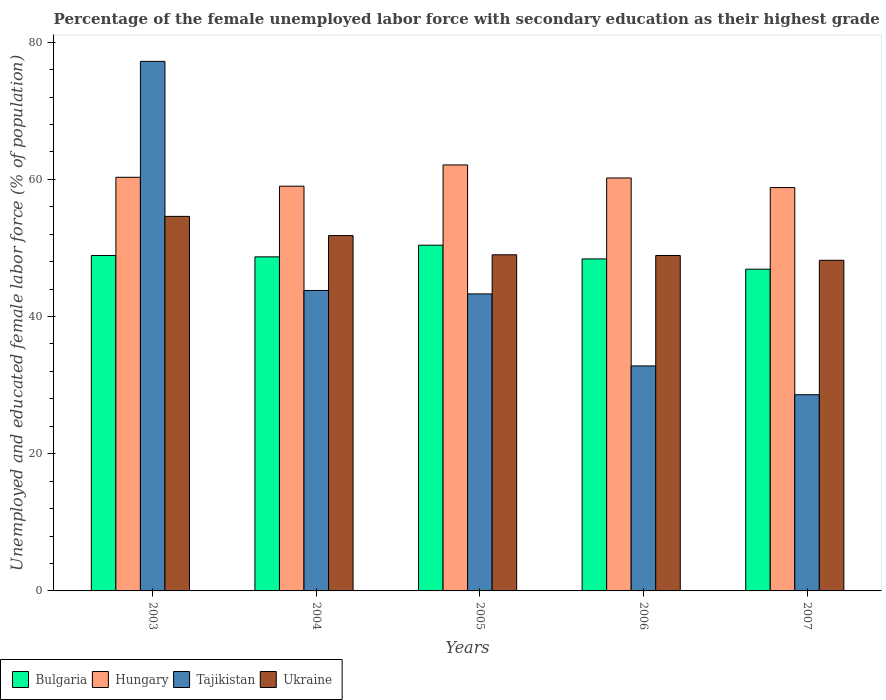How many different coloured bars are there?
Make the answer very short. 4. How many groups of bars are there?
Give a very brief answer. 5. Are the number of bars on each tick of the X-axis equal?
Your answer should be compact. Yes. What is the label of the 3rd group of bars from the left?
Keep it short and to the point. 2005. In how many cases, is the number of bars for a given year not equal to the number of legend labels?
Offer a terse response. 0. What is the percentage of the unemployed female labor force with secondary education in Bulgaria in 2005?
Offer a very short reply. 50.4. Across all years, what is the maximum percentage of the unemployed female labor force with secondary education in Tajikistan?
Provide a succinct answer. 77.2. Across all years, what is the minimum percentage of the unemployed female labor force with secondary education in Tajikistan?
Offer a very short reply. 28.6. In which year was the percentage of the unemployed female labor force with secondary education in Ukraine maximum?
Your response must be concise. 2003. In which year was the percentage of the unemployed female labor force with secondary education in Tajikistan minimum?
Provide a short and direct response. 2007. What is the total percentage of the unemployed female labor force with secondary education in Tajikistan in the graph?
Provide a short and direct response. 225.7. What is the difference between the percentage of the unemployed female labor force with secondary education in Tajikistan in 2003 and that in 2007?
Keep it short and to the point. 48.6. What is the average percentage of the unemployed female labor force with secondary education in Tajikistan per year?
Keep it short and to the point. 45.14. In the year 2004, what is the difference between the percentage of the unemployed female labor force with secondary education in Hungary and percentage of the unemployed female labor force with secondary education in Bulgaria?
Offer a terse response. 10.3. In how many years, is the percentage of the unemployed female labor force with secondary education in Hungary greater than 16 %?
Your response must be concise. 5. What is the ratio of the percentage of the unemployed female labor force with secondary education in Bulgaria in 2004 to that in 2007?
Your answer should be very brief. 1.04. Is the difference between the percentage of the unemployed female labor force with secondary education in Hungary in 2004 and 2007 greater than the difference between the percentage of the unemployed female labor force with secondary education in Bulgaria in 2004 and 2007?
Ensure brevity in your answer.  No. What is the difference between the highest and the second highest percentage of the unemployed female labor force with secondary education in Tajikistan?
Ensure brevity in your answer.  33.4. Is it the case that in every year, the sum of the percentage of the unemployed female labor force with secondary education in Bulgaria and percentage of the unemployed female labor force with secondary education in Ukraine is greater than the sum of percentage of the unemployed female labor force with secondary education in Hungary and percentage of the unemployed female labor force with secondary education in Tajikistan?
Offer a very short reply. No. What does the 4th bar from the left in 2003 represents?
Your answer should be compact. Ukraine. What does the 2nd bar from the right in 2006 represents?
Give a very brief answer. Tajikistan. Are the values on the major ticks of Y-axis written in scientific E-notation?
Ensure brevity in your answer.  No. Does the graph contain any zero values?
Offer a terse response. No. Does the graph contain grids?
Offer a terse response. No. Where does the legend appear in the graph?
Ensure brevity in your answer.  Bottom left. How many legend labels are there?
Ensure brevity in your answer.  4. What is the title of the graph?
Provide a short and direct response. Percentage of the female unemployed labor force with secondary education as their highest grade. What is the label or title of the Y-axis?
Keep it short and to the point. Unemployed and educated female labor force (% of population). What is the Unemployed and educated female labor force (% of population) of Bulgaria in 2003?
Your response must be concise. 48.9. What is the Unemployed and educated female labor force (% of population) of Hungary in 2003?
Offer a very short reply. 60.3. What is the Unemployed and educated female labor force (% of population) of Tajikistan in 2003?
Keep it short and to the point. 77.2. What is the Unemployed and educated female labor force (% of population) in Ukraine in 2003?
Your response must be concise. 54.6. What is the Unemployed and educated female labor force (% of population) of Bulgaria in 2004?
Provide a succinct answer. 48.7. What is the Unemployed and educated female labor force (% of population) of Hungary in 2004?
Provide a succinct answer. 59. What is the Unemployed and educated female labor force (% of population) of Tajikistan in 2004?
Your response must be concise. 43.8. What is the Unemployed and educated female labor force (% of population) in Ukraine in 2004?
Make the answer very short. 51.8. What is the Unemployed and educated female labor force (% of population) in Bulgaria in 2005?
Your response must be concise. 50.4. What is the Unemployed and educated female labor force (% of population) in Hungary in 2005?
Provide a succinct answer. 62.1. What is the Unemployed and educated female labor force (% of population) in Tajikistan in 2005?
Offer a very short reply. 43.3. What is the Unemployed and educated female labor force (% of population) in Ukraine in 2005?
Ensure brevity in your answer.  49. What is the Unemployed and educated female labor force (% of population) in Bulgaria in 2006?
Offer a very short reply. 48.4. What is the Unemployed and educated female labor force (% of population) in Hungary in 2006?
Give a very brief answer. 60.2. What is the Unemployed and educated female labor force (% of population) of Tajikistan in 2006?
Provide a succinct answer. 32.8. What is the Unemployed and educated female labor force (% of population) of Ukraine in 2006?
Your answer should be compact. 48.9. What is the Unemployed and educated female labor force (% of population) in Bulgaria in 2007?
Offer a very short reply. 46.9. What is the Unemployed and educated female labor force (% of population) of Hungary in 2007?
Your answer should be very brief. 58.8. What is the Unemployed and educated female labor force (% of population) in Tajikistan in 2007?
Provide a succinct answer. 28.6. What is the Unemployed and educated female labor force (% of population) of Ukraine in 2007?
Ensure brevity in your answer.  48.2. Across all years, what is the maximum Unemployed and educated female labor force (% of population) in Bulgaria?
Your answer should be very brief. 50.4. Across all years, what is the maximum Unemployed and educated female labor force (% of population) in Hungary?
Your answer should be very brief. 62.1. Across all years, what is the maximum Unemployed and educated female labor force (% of population) of Tajikistan?
Offer a terse response. 77.2. Across all years, what is the maximum Unemployed and educated female labor force (% of population) in Ukraine?
Offer a terse response. 54.6. Across all years, what is the minimum Unemployed and educated female labor force (% of population) in Bulgaria?
Keep it short and to the point. 46.9. Across all years, what is the minimum Unemployed and educated female labor force (% of population) of Hungary?
Give a very brief answer. 58.8. Across all years, what is the minimum Unemployed and educated female labor force (% of population) of Tajikistan?
Give a very brief answer. 28.6. Across all years, what is the minimum Unemployed and educated female labor force (% of population) in Ukraine?
Make the answer very short. 48.2. What is the total Unemployed and educated female labor force (% of population) in Bulgaria in the graph?
Ensure brevity in your answer.  243.3. What is the total Unemployed and educated female labor force (% of population) of Hungary in the graph?
Keep it short and to the point. 300.4. What is the total Unemployed and educated female labor force (% of population) of Tajikistan in the graph?
Ensure brevity in your answer.  225.7. What is the total Unemployed and educated female labor force (% of population) in Ukraine in the graph?
Offer a terse response. 252.5. What is the difference between the Unemployed and educated female labor force (% of population) of Hungary in 2003 and that in 2004?
Keep it short and to the point. 1.3. What is the difference between the Unemployed and educated female labor force (% of population) in Tajikistan in 2003 and that in 2004?
Keep it short and to the point. 33.4. What is the difference between the Unemployed and educated female labor force (% of population) of Ukraine in 2003 and that in 2004?
Make the answer very short. 2.8. What is the difference between the Unemployed and educated female labor force (% of population) of Bulgaria in 2003 and that in 2005?
Give a very brief answer. -1.5. What is the difference between the Unemployed and educated female labor force (% of population) of Hungary in 2003 and that in 2005?
Your answer should be compact. -1.8. What is the difference between the Unemployed and educated female labor force (% of population) of Tajikistan in 2003 and that in 2005?
Your response must be concise. 33.9. What is the difference between the Unemployed and educated female labor force (% of population) of Ukraine in 2003 and that in 2005?
Your response must be concise. 5.6. What is the difference between the Unemployed and educated female labor force (% of population) in Tajikistan in 2003 and that in 2006?
Your answer should be compact. 44.4. What is the difference between the Unemployed and educated female labor force (% of population) in Bulgaria in 2003 and that in 2007?
Ensure brevity in your answer.  2. What is the difference between the Unemployed and educated female labor force (% of population) of Hungary in 2003 and that in 2007?
Make the answer very short. 1.5. What is the difference between the Unemployed and educated female labor force (% of population) in Tajikistan in 2003 and that in 2007?
Your answer should be very brief. 48.6. What is the difference between the Unemployed and educated female labor force (% of population) of Bulgaria in 2004 and that in 2005?
Keep it short and to the point. -1.7. What is the difference between the Unemployed and educated female labor force (% of population) in Tajikistan in 2004 and that in 2005?
Make the answer very short. 0.5. What is the difference between the Unemployed and educated female labor force (% of population) in Ukraine in 2004 and that in 2005?
Your answer should be compact. 2.8. What is the difference between the Unemployed and educated female labor force (% of population) in Hungary in 2004 and that in 2006?
Keep it short and to the point. -1.2. What is the difference between the Unemployed and educated female labor force (% of population) of Bulgaria in 2004 and that in 2007?
Ensure brevity in your answer.  1.8. What is the difference between the Unemployed and educated female labor force (% of population) in Tajikistan in 2004 and that in 2007?
Provide a short and direct response. 15.2. What is the difference between the Unemployed and educated female labor force (% of population) in Ukraine in 2005 and that in 2006?
Your answer should be compact. 0.1. What is the difference between the Unemployed and educated female labor force (% of population) of Tajikistan in 2005 and that in 2007?
Make the answer very short. 14.7. What is the difference between the Unemployed and educated female labor force (% of population) of Bulgaria in 2006 and that in 2007?
Make the answer very short. 1.5. What is the difference between the Unemployed and educated female labor force (% of population) of Tajikistan in 2006 and that in 2007?
Offer a terse response. 4.2. What is the difference between the Unemployed and educated female labor force (% of population) in Bulgaria in 2003 and the Unemployed and educated female labor force (% of population) in Hungary in 2004?
Your answer should be compact. -10.1. What is the difference between the Unemployed and educated female labor force (% of population) in Bulgaria in 2003 and the Unemployed and educated female labor force (% of population) in Tajikistan in 2004?
Offer a very short reply. 5.1. What is the difference between the Unemployed and educated female labor force (% of population) in Bulgaria in 2003 and the Unemployed and educated female labor force (% of population) in Ukraine in 2004?
Make the answer very short. -2.9. What is the difference between the Unemployed and educated female labor force (% of population) in Hungary in 2003 and the Unemployed and educated female labor force (% of population) in Ukraine in 2004?
Your response must be concise. 8.5. What is the difference between the Unemployed and educated female labor force (% of population) in Tajikistan in 2003 and the Unemployed and educated female labor force (% of population) in Ukraine in 2004?
Offer a terse response. 25.4. What is the difference between the Unemployed and educated female labor force (% of population) in Bulgaria in 2003 and the Unemployed and educated female labor force (% of population) in Hungary in 2005?
Make the answer very short. -13.2. What is the difference between the Unemployed and educated female labor force (% of population) in Bulgaria in 2003 and the Unemployed and educated female labor force (% of population) in Tajikistan in 2005?
Offer a terse response. 5.6. What is the difference between the Unemployed and educated female labor force (% of population) of Bulgaria in 2003 and the Unemployed and educated female labor force (% of population) of Ukraine in 2005?
Keep it short and to the point. -0.1. What is the difference between the Unemployed and educated female labor force (% of population) in Hungary in 2003 and the Unemployed and educated female labor force (% of population) in Ukraine in 2005?
Give a very brief answer. 11.3. What is the difference between the Unemployed and educated female labor force (% of population) in Tajikistan in 2003 and the Unemployed and educated female labor force (% of population) in Ukraine in 2005?
Your response must be concise. 28.2. What is the difference between the Unemployed and educated female labor force (% of population) in Bulgaria in 2003 and the Unemployed and educated female labor force (% of population) in Tajikistan in 2006?
Provide a succinct answer. 16.1. What is the difference between the Unemployed and educated female labor force (% of population) of Bulgaria in 2003 and the Unemployed and educated female labor force (% of population) of Ukraine in 2006?
Your answer should be compact. 0. What is the difference between the Unemployed and educated female labor force (% of population) in Tajikistan in 2003 and the Unemployed and educated female labor force (% of population) in Ukraine in 2006?
Your answer should be compact. 28.3. What is the difference between the Unemployed and educated female labor force (% of population) in Bulgaria in 2003 and the Unemployed and educated female labor force (% of population) in Tajikistan in 2007?
Provide a short and direct response. 20.3. What is the difference between the Unemployed and educated female labor force (% of population) of Hungary in 2003 and the Unemployed and educated female labor force (% of population) of Tajikistan in 2007?
Provide a succinct answer. 31.7. What is the difference between the Unemployed and educated female labor force (% of population) in Tajikistan in 2003 and the Unemployed and educated female labor force (% of population) in Ukraine in 2007?
Provide a short and direct response. 29. What is the difference between the Unemployed and educated female labor force (% of population) in Bulgaria in 2004 and the Unemployed and educated female labor force (% of population) in Tajikistan in 2005?
Give a very brief answer. 5.4. What is the difference between the Unemployed and educated female labor force (% of population) of Bulgaria in 2004 and the Unemployed and educated female labor force (% of population) of Ukraine in 2005?
Offer a terse response. -0.3. What is the difference between the Unemployed and educated female labor force (% of population) in Tajikistan in 2004 and the Unemployed and educated female labor force (% of population) in Ukraine in 2005?
Offer a very short reply. -5.2. What is the difference between the Unemployed and educated female labor force (% of population) of Bulgaria in 2004 and the Unemployed and educated female labor force (% of population) of Tajikistan in 2006?
Your answer should be very brief. 15.9. What is the difference between the Unemployed and educated female labor force (% of population) in Bulgaria in 2004 and the Unemployed and educated female labor force (% of population) in Ukraine in 2006?
Keep it short and to the point. -0.2. What is the difference between the Unemployed and educated female labor force (% of population) in Hungary in 2004 and the Unemployed and educated female labor force (% of population) in Tajikistan in 2006?
Your answer should be very brief. 26.2. What is the difference between the Unemployed and educated female labor force (% of population) of Hungary in 2004 and the Unemployed and educated female labor force (% of population) of Ukraine in 2006?
Your response must be concise. 10.1. What is the difference between the Unemployed and educated female labor force (% of population) of Bulgaria in 2004 and the Unemployed and educated female labor force (% of population) of Hungary in 2007?
Your response must be concise. -10.1. What is the difference between the Unemployed and educated female labor force (% of population) in Bulgaria in 2004 and the Unemployed and educated female labor force (% of population) in Tajikistan in 2007?
Keep it short and to the point. 20.1. What is the difference between the Unemployed and educated female labor force (% of population) of Hungary in 2004 and the Unemployed and educated female labor force (% of population) of Tajikistan in 2007?
Your answer should be very brief. 30.4. What is the difference between the Unemployed and educated female labor force (% of population) of Hungary in 2004 and the Unemployed and educated female labor force (% of population) of Ukraine in 2007?
Offer a terse response. 10.8. What is the difference between the Unemployed and educated female labor force (% of population) of Tajikistan in 2004 and the Unemployed and educated female labor force (% of population) of Ukraine in 2007?
Keep it short and to the point. -4.4. What is the difference between the Unemployed and educated female labor force (% of population) in Bulgaria in 2005 and the Unemployed and educated female labor force (% of population) in Hungary in 2006?
Your response must be concise. -9.8. What is the difference between the Unemployed and educated female labor force (% of population) in Hungary in 2005 and the Unemployed and educated female labor force (% of population) in Tajikistan in 2006?
Offer a very short reply. 29.3. What is the difference between the Unemployed and educated female labor force (% of population) of Hungary in 2005 and the Unemployed and educated female labor force (% of population) of Ukraine in 2006?
Your answer should be compact. 13.2. What is the difference between the Unemployed and educated female labor force (% of population) in Bulgaria in 2005 and the Unemployed and educated female labor force (% of population) in Hungary in 2007?
Keep it short and to the point. -8.4. What is the difference between the Unemployed and educated female labor force (% of population) in Bulgaria in 2005 and the Unemployed and educated female labor force (% of population) in Tajikistan in 2007?
Provide a succinct answer. 21.8. What is the difference between the Unemployed and educated female labor force (% of population) in Hungary in 2005 and the Unemployed and educated female labor force (% of population) in Tajikistan in 2007?
Provide a succinct answer. 33.5. What is the difference between the Unemployed and educated female labor force (% of population) in Hungary in 2005 and the Unemployed and educated female labor force (% of population) in Ukraine in 2007?
Offer a very short reply. 13.9. What is the difference between the Unemployed and educated female labor force (% of population) in Tajikistan in 2005 and the Unemployed and educated female labor force (% of population) in Ukraine in 2007?
Your response must be concise. -4.9. What is the difference between the Unemployed and educated female labor force (% of population) in Bulgaria in 2006 and the Unemployed and educated female labor force (% of population) in Hungary in 2007?
Provide a succinct answer. -10.4. What is the difference between the Unemployed and educated female labor force (% of population) of Bulgaria in 2006 and the Unemployed and educated female labor force (% of population) of Tajikistan in 2007?
Provide a succinct answer. 19.8. What is the difference between the Unemployed and educated female labor force (% of population) in Hungary in 2006 and the Unemployed and educated female labor force (% of population) in Tajikistan in 2007?
Make the answer very short. 31.6. What is the difference between the Unemployed and educated female labor force (% of population) in Hungary in 2006 and the Unemployed and educated female labor force (% of population) in Ukraine in 2007?
Your answer should be very brief. 12. What is the difference between the Unemployed and educated female labor force (% of population) in Tajikistan in 2006 and the Unemployed and educated female labor force (% of population) in Ukraine in 2007?
Keep it short and to the point. -15.4. What is the average Unemployed and educated female labor force (% of population) in Bulgaria per year?
Make the answer very short. 48.66. What is the average Unemployed and educated female labor force (% of population) of Hungary per year?
Make the answer very short. 60.08. What is the average Unemployed and educated female labor force (% of population) in Tajikistan per year?
Give a very brief answer. 45.14. What is the average Unemployed and educated female labor force (% of population) of Ukraine per year?
Give a very brief answer. 50.5. In the year 2003, what is the difference between the Unemployed and educated female labor force (% of population) of Bulgaria and Unemployed and educated female labor force (% of population) of Hungary?
Your answer should be very brief. -11.4. In the year 2003, what is the difference between the Unemployed and educated female labor force (% of population) of Bulgaria and Unemployed and educated female labor force (% of population) of Tajikistan?
Give a very brief answer. -28.3. In the year 2003, what is the difference between the Unemployed and educated female labor force (% of population) of Hungary and Unemployed and educated female labor force (% of population) of Tajikistan?
Give a very brief answer. -16.9. In the year 2003, what is the difference between the Unemployed and educated female labor force (% of population) in Tajikistan and Unemployed and educated female labor force (% of population) in Ukraine?
Give a very brief answer. 22.6. In the year 2004, what is the difference between the Unemployed and educated female labor force (% of population) in Hungary and Unemployed and educated female labor force (% of population) in Ukraine?
Keep it short and to the point. 7.2. In the year 2005, what is the difference between the Unemployed and educated female labor force (% of population) of Bulgaria and Unemployed and educated female labor force (% of population) of Tajikistan?
Offer a very short reply. 7.1. In the year 2005, what is the difference between the Unemployed and educated female labor force (% of population) of Bulgaria and Unemployed and educated female labor force (% of population) of Ukraine?
Give a very brief answer. 1.4. In the year 2006, what is the difference between the Unemployed and educated female labor force (% of population) of Bulgaria and Unemployed and educated female labor force (% of population) of Hungary?
Your answer should be very brief. -11.8. In the year 2006, what is the difference between the Unemployed and educated female labor force (% of population) in Bulgaria and Unemployed and educated female labor force (% of population) in Ukraine?
Offer a terse response. -0.5. In the year 2006, what is the difference between the Unemployed and educated female labor force (% of population) in Hungary and Unemployed and educated female labor force (% of population) in Tajikistan?
Provide a short and direct response. 27.4. In the year 2006, what is the difference between the Unemployed and educated female labor force (% of population) of Hungary and Unemployed and educated female labor force (% of population) of Ukraine?
Your answer should be compact. 11.3. In the year 2006, what is the difference between the Unemployed and educated female labor force (% of population) in Tajikistan and Unemployed and educated female labor force (% of population) in Ukraine?
Keep it short and to the point. -16.1. In the year 2007, what is the difference between the Unemployed and educated female labor force (% of population) in Bulgaria and Unemployed and educated female labor force (% of population) in Ukraine?
Provide a succinct answer. -1.3. In the year 2007, what is the difference between the Unemployed and educated female labor force (% of population) in Hungary and Unemployed and educated female labor force (% of population) in Tajikistan?
Give a very brief answer. 30.2. In the year 2007, what is the difference between the Unemployed and educated female labor force (% of population) in Hungary and Unemployed and educated female labor force (% of population) in Ukraine?
Your answer should be compact. 10.6. In the year 2007, what is the difference between the Unemployed and educated female labor force (% of population) of Tajikistan and Unemployed and educated female labor force (% of population) of Ukraine?
Provide a short and direct response. -19.6. What is the ratio of the Unemployed and educated female labor force (% of population) in Bulgaria in 2003 to that in 2004?
Your answer should be very brief. 1. What is the ratio of the Unemployed and educated female labor force (% of population) in Hungary in 2003 to that in 2004?
Your answer should be compact. 1.02. What is the ratio of the Unemployed and educated female labor force (% of population) of Tajikistan in 2003 to that in 2004?
Provide a succinct answer. 1.76. What is the ratio of the Unemployed and educated female labor force (% of population) of Ukraine in 2003 to that in 2004?
Offer a terse response. 1.05. What is the ratio of the Unemployed and educated female labor force (% of population) of Bulgaria in 2003 to that in 2005?
Keep it short and to the point. 0.97. What is the ratio of the Unemployed and educated female labor force (% of population) in Hungary in 2003 to that in 2005?
Offer a terse response. 0.97. What is the ratio of the Unemployed and educated female labor force (% of population) of Tajikistan in 2003 to that in 2005?
Your answer should be very brief. 1.78. What is the ratio of the Unemployed and educated female labor force (% of population) of Ukraine in 2003 to that in 2005?
Keep it short and to the point. 1.11. What is the ratio of the Unemployed and educated female labor force (% of population) of Bulgaria in 2003 to that in 2006?
Provide a short and direct response. 1.01. What is the ratio of the Unemployed and educated female labor force (% of population) in Hungary in 2003 to that in 2006?
Offer a terse response. 1. What is the ratio of the Unemployed and educated female labor force (% of population) in Tajikistan in 2003 to that in 2006?
Your answer should be compact. 2.35. What is the ratio of the Unemployed and educated female labor force (% of population) in Ukraine in 2003 to that in 2006?
Provide a succinct answer. 1.12. What is the ratio of the Unemployed and educated female labor force (% of population) of Bulgaria in 2003 to that in 2007?
Your answer should be very brief. 1.04. What is the ratio of the Unemployed and educated female labor force (% of population) of Hungary in 2003 to that in 2007?
Make the answer very short. 1.03. What is the ratio of the Unemployed and educated female labor force (% of population) of Tajikistan in 2003 to that in 2007?
Your answer should be compact. 2.7. What is the ratio of the Unemployed and educated female labor force (% of population) in Ukraine in 2003 to that in 2007?
Provide a short and direct response. 1.13. What is the ratio of the Unemployed and educated female labor force (% of population) in Bulgaria in 2004 to that in 2005?
Provide a succinct answer. 0.97. What is the ratio of the Unemployed and educated female labor force (% of population) of Hungary in 2004 to that in 2005?
Make the answer very short. 0.95. What is the ratio of the Unemployed and educated female labor force (% of population) of Tajikistan in 2004 to that in 2005?
Your answer should be very brief. 1.01. What is the ratio of the Unemployed and educated female labor force (% of population) of Ukraine in 2004 to that in 2005?
Keep it short and to the point. 1.06. What is the ratio of the Unemployed and educated female labor force (% of population) in Bulgaria in 2004 to that in 2006?
Provide a short and direct response. 1.01. What is the ratio of the Unemployed and educated female labor force (% of population) in Hungary in 2004 to that in 2006?
Offer a terse response. 0.98. What is the ratio of the Unemployed and educated female labor force (% of population) in Tajikistan in 2004 to that in 2006?
Keep it short and to the point. 1.34. What is the ratio of the Unemployed and educated female labor force (% of population) of Ukraine in 2004 to that in 2006?
Keep it short and to the point. 1.06. What is the ratio of the Unemployed and educated female labor force (% of population) in Bulgaria in 2004 to that in 2007?
Offer a terse response. 1.04. What is the ratio of the Unemployed and educated female labor force (% of population) of Tajikistan in 2004 to that in 2007?
Your answer should be compact. 1.53. What is the ratio of the Unemployed and educated female labor force (% of population) in Ukraine in 2004 to that in 2007?
Make the answer very short. 1.07. What is the ratio of the Unemployed and educated female labor force (% of population) in Bulgaria in 2005 to that in 2006?
Offer a very short reply. 1.04. What is the ratio of the Unemployed and educated female labor force (% of population) in Hungary in 2005 to that in 2006?
Offer a very short reply. 1.03. What is the ratio of the Unemployed and educated female labor force (% of population) of Tajikistan in 2005 to that in 2006?
Ensure brevity in your answer.  1.32. What is the ratio of the Unemployed and educated female labor force (% of population) in Bulgaria in 2005 to that in 2007?
Ensure brevity in your answer.  1.07. What is the ratio of the Unemployed and educated female labor force (% of population) in Hungary in 2005 to that in 2007?
Your answer should be compact. 1.06. What is the ratio of the Unemployed and educated female labor force (% of population) in Tajikistan in 2005 to that in 2007?
Your response must be concise. 1.51. What is the ratio of the Unemployed and educated female labor force (% of population) in Ukraine in 2005 to that in 2007?
Your answer should be compact. 1.02. What is the ratio of the Unemployed and educated female labor force (% of population) of Bulgaria in 2006 to that in 2007?
Offer a terse response. 1.03. What is the ratio of the Unemployed and educated female labor force (% of population) of Hungary in 2006 to that in 2007?
Provide a succinct answer. 1.02. What is the ratio of the Unemployed and educated female labor force (% of population) in Tajikistan in 2006 to that in 2007?
Make the answer very short. 1.15. What is the ratio of the Unemployed and educated female labor force (% of population) in Ukraine in 2006 to that in 2007?
Your answer should be compact. 1.01. What is the difference between the highest and the second highest Unemployed and educated female labor force (% of population) of Tajikistan?
Keep it short and to the point. 33.4. What is the difference between the highest and the second highest Unemployed and educated female labor force (% of population) in Ukraine?
Your response must be concise. 2.8. What is the difference between the highest and the lowest Unemployed and educated female labor force (% of population) in Hungary?
Give a very brief answer. 3.3. What is the difference between the highest and the lowest Unemployed and educated female labor force (% of population) in Tajikistan?
Give a very brief answer. 48.6. What is the difference between the highest and the lowest Unemployed and educated female labor force (% of population) of Ukraine?
Make the answer very short. 6.4. 